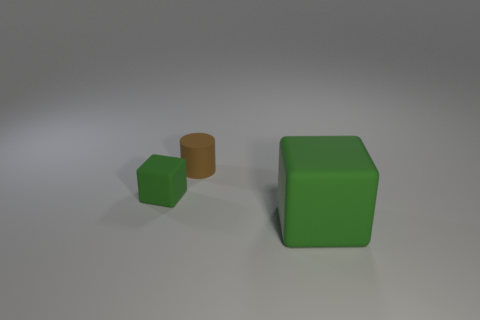Add 2 yellow metal cubes. How many objects exist? 5 Subtract all cylinders. How many objects are left? 2 Add 1 tiny brown objects. How many tiny brown objects exist? 2 Subtract 0 gray blocks. How many objects are left? 3 Subtract all large green objects. Subtract all brown objects. How many objects are left? 1 Add 2 small green matte things. How many small green matte things are left? 3 